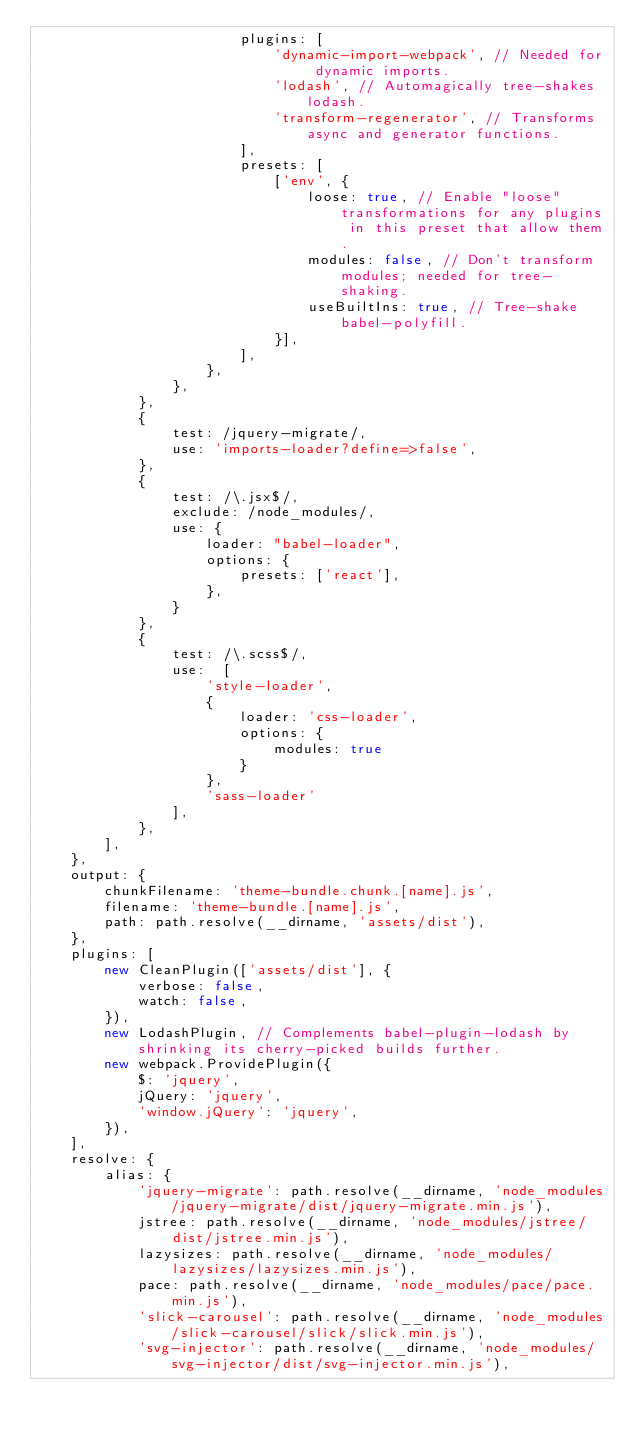Convert code to text. <code><loc_0><loc_0><loc_500><loc_500><_JavaScript_>                        plugins: [
                            'dynamic-import-webpack', // Needed for dynamic imports.
                            'lodash', // Automagically tree-shakes lodash.
                            'transform-regenerator', // Transforms async and generator functions.
                        ],
                        presets: [
                            ['env', {
                                loose: true, // Enable "loose" transformations for any plugins in this preset that allow them.
                                modules: false, // Don't transform modules; needed for tree-shaking.
                                useBuiltIns: true, // Tree-shake babel-polyfill.
                            }],
                        ],
                    },
                },
            },
            {
                test: /jquery-migrate/,
                use: 'imports-loader?define=>false',
            },
            {
                test: /\.jsx$/,
                exclude: /node_modules/,
                use: {
                    loader: "babel-loader",
                    options: {
                        presets: ['react'],
                    },
                }
            },
            {
                test: /\.scss$/,
                use:  [
                    'style-loader',
                    {
                        loader: 'css-loader',
                        options: {
                            modules: true
                        }
                    },
                    'sass-loader'
                ],
            },            
        ],
    },
    output: {
        chunkFilename: 'theme-bundle.chunk.[name].js',
        filename: 'theme-bundle.[name].js',
        path: path.resolve(__dirname, 'assets/dist'),
    },
    plugins: [
        new CleanPlugin(['assets/dist'], {
            verbose: false,
            watch: false,
        }),
        new LodashPlugin, // Complements babel-plugin-lodash by shrinking its cherry-picked builds further.
        new webpack.ProvidePlugin({
            $: 'jquery',
            jQuery: 'jquery',
            'window.jQuery': 'jquery',
        }),
    ],
    resolve: {
        alias: {
            'jquery-migrate': path.resolve(__dirname, 'node_modules/jquery-migrate/dist/jquery-migrate.min.js'),
            jstree: path.resolve(__dirname, 'node_modules/jstree/dist/jstree.min.js'),
            lazysizes: path.resolve(__dirname, 'node_modules/lazysizes/lazysizes.min.js'),
            pace: path.resolve(__dirname, 'node_modules/pace/pace.min.js'),
            'slick-carousel': path.resolve(__dirname, 'node_modules/slick-carousel/slick/slick.min.js'),
            'svg-injector': path.resolve(__dirname, 'node_modules/svg-injector/dist/svg-injector.min.js'),</code> 